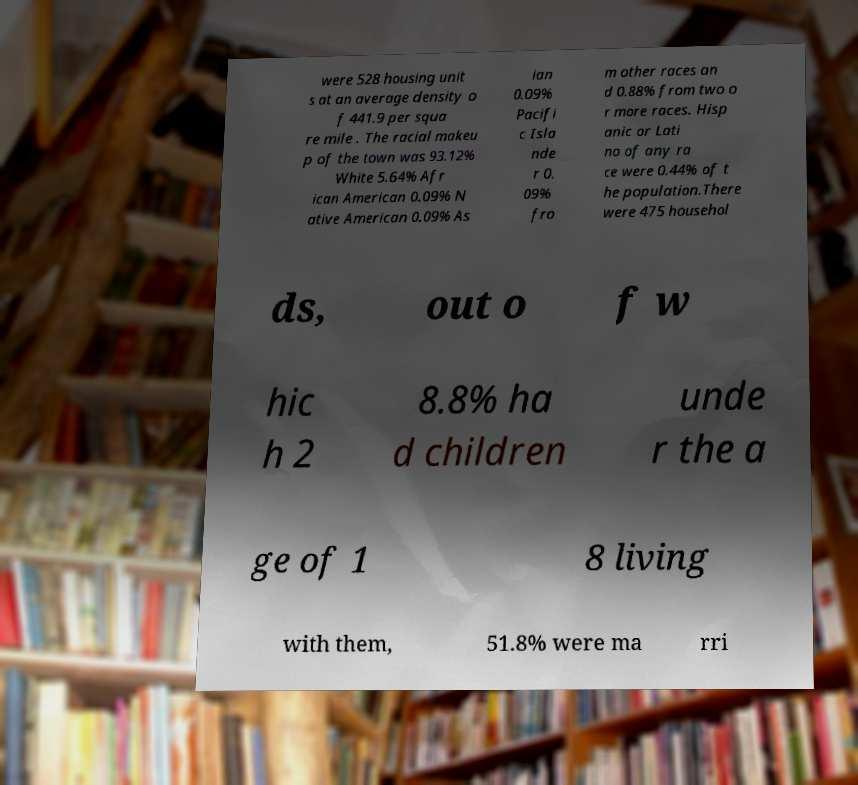Can you read and provide the text displayed in the image?This photo seems to have some interesting text. Can you extract and type it out for me? were 528 housing unit s at an average density o f 441.9 per squa re mile . The racial makeu p of the town was 93.12% White 5.64% Afr ican American 0.09% N ative American 0.09% As ian 0.09% Pacifi c Isla nde r 0. 09% fro m other races an d 0.88% from two o r more races. Hisp anic or Lati no of any ra ce were 0.44% of t he population.There were 475 househol ds, out o f w hic h 2 8.8% ha d children unde r the a ge of 1 8 living with them, 51.8% were ma rri 